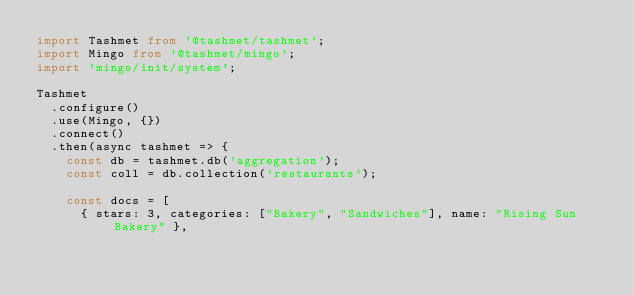<code> <loc_0><loc_0><loc_500><loc_500><_TypeScript_>import Tashmet from '@tashmet/tashmet';
import Mingo from '@tashmet/mingo';
import 'mingo/init/system';

Tashmet
  .configure()
  .use(Mingo, {})
  .connect()
  .then(async tashmet => {
    const db = tashmet.db('aggregation');
    const coll = db.collection('restaurants');

    const docs = [
      { stars: 3, categories: ["Bakery", "Sandwiches"], name: "Rising Sun Bakery" },</code> 